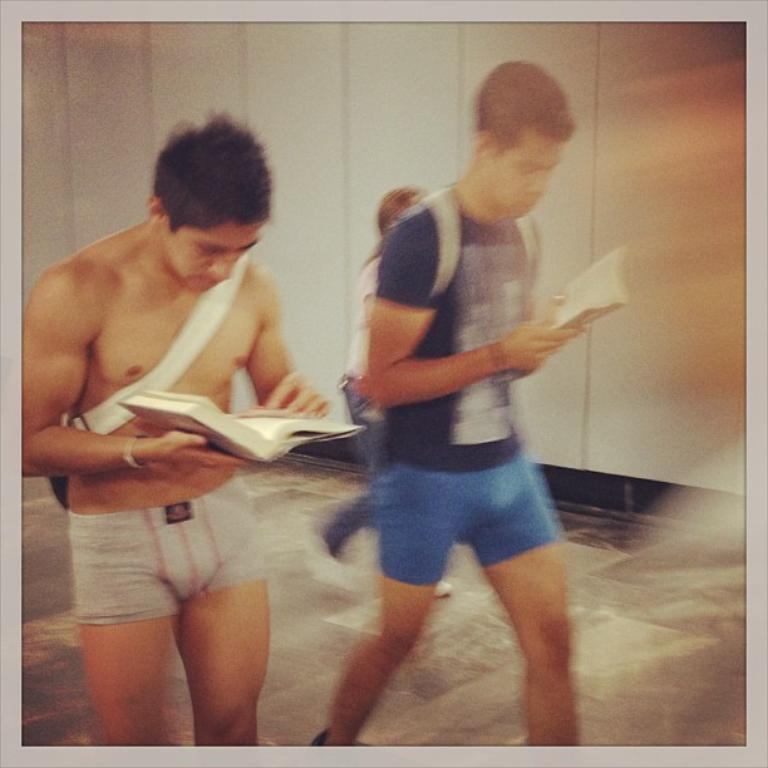Who or what can be seen in the image? There are people in the image. What are the people doing? The people are walking. What are the people holding while walking? The people are holding books. What can be seen in the background of the image? There is a wall visible in the image. What type of scale can be seen in the image? There is no scale present in the image. What kind of curve is visible in the image? There is no curve visible in the image. 